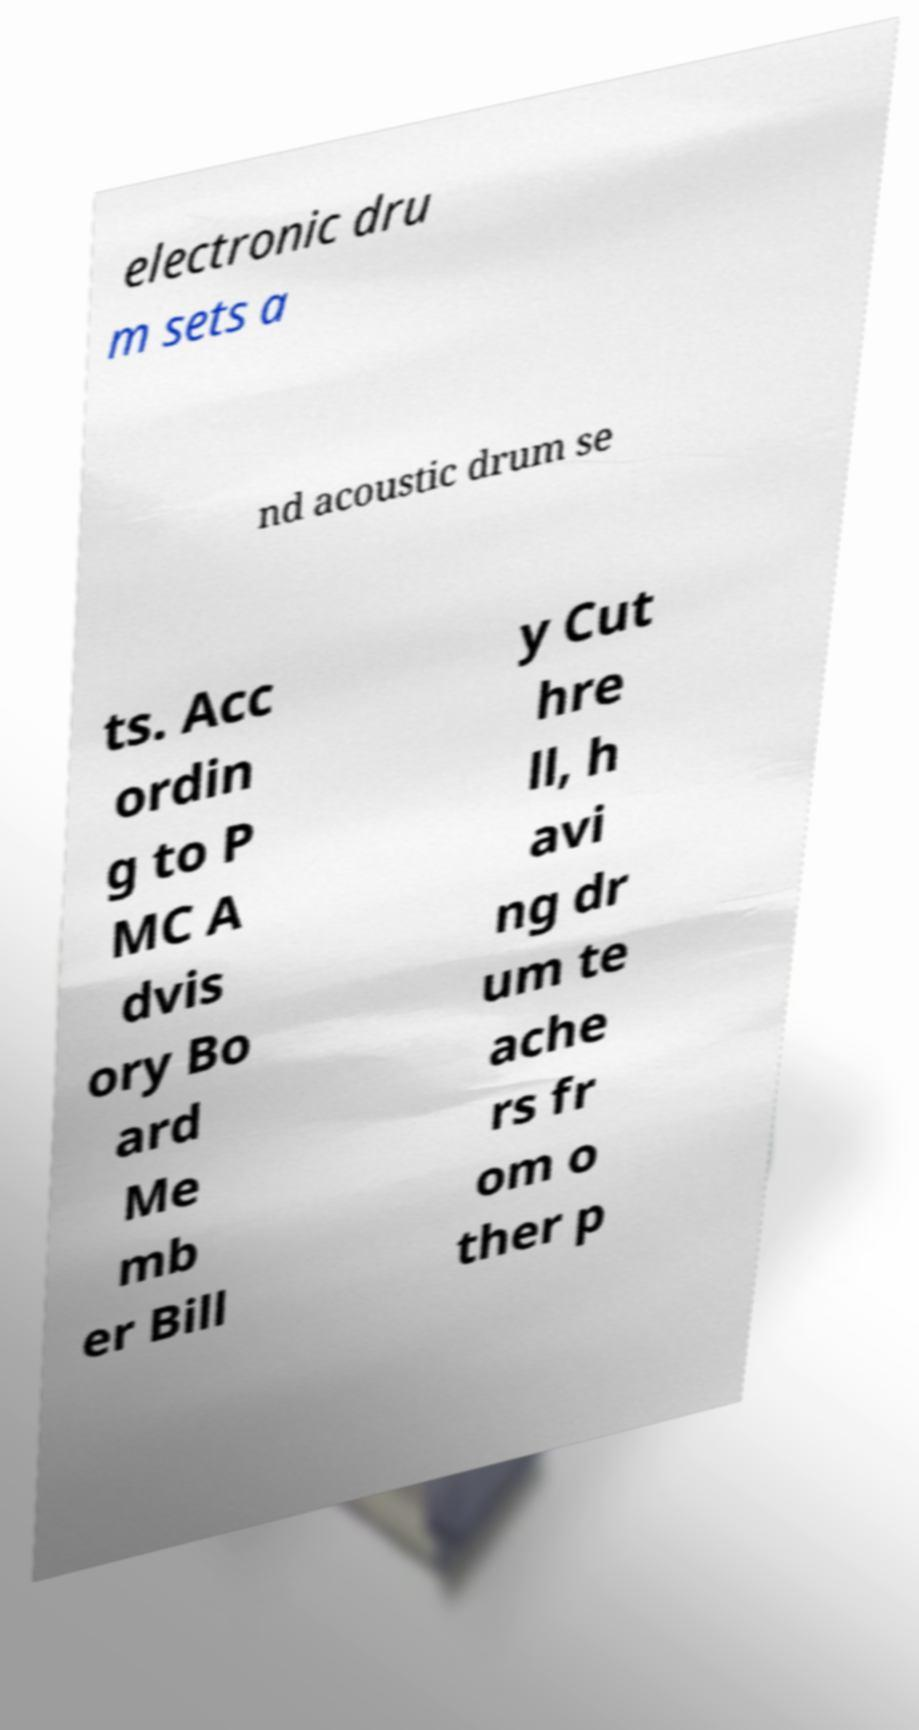I need the written content from this picture converted into text. Can you do that? electronic dru m sets a nd acoustic drum se ts. Acc ordin g to P MC A dvis ory Bo ard Me mb er Bill y Cut hre ll, h avi ng dr um te ache rs fr om o ther p 